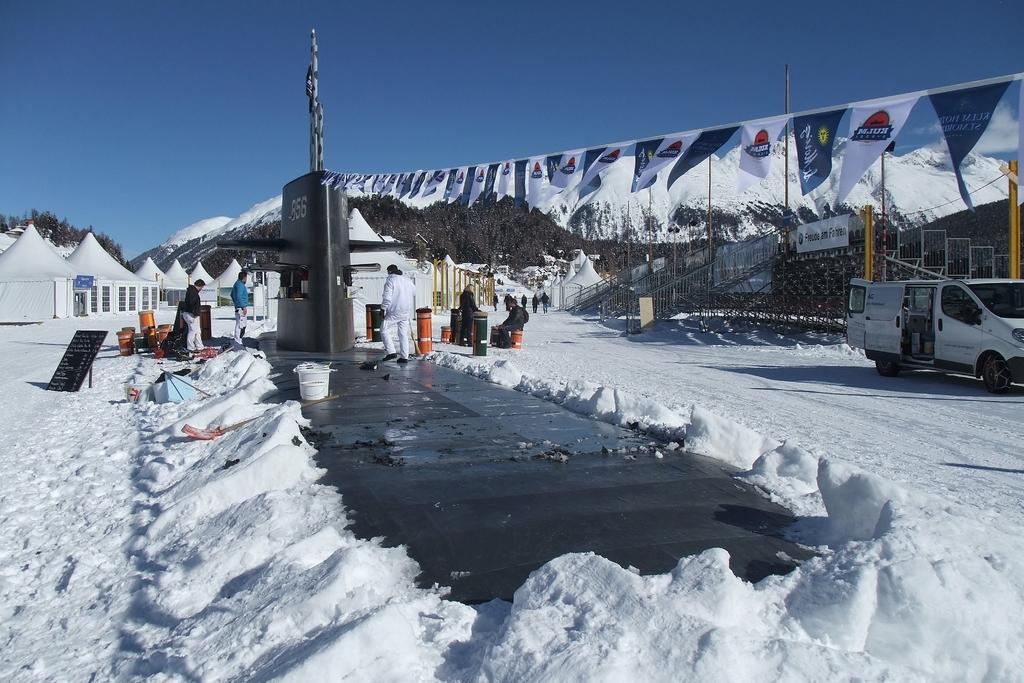What is the weather like in the image? The weather in the image is characterized by snow. What type of vehicle can be seen in the image? There is a vehicle in the image. Can you describe the people in the image? There are people in the image. What do the banners in the image indicate? The presence of banners suggests that there might be an event or gathering taking place. What else can be seen in the image besides the people and the vehicle? There are objects in the image. What is visible in the background of the image? In the background of the image, there are trees and sky. What type of skin condition can be seen on the people in the image? There is no indication of any skin condition on the people in the image. What kind of pets are accompanying the people in the image? There are no pets visible in the image. 